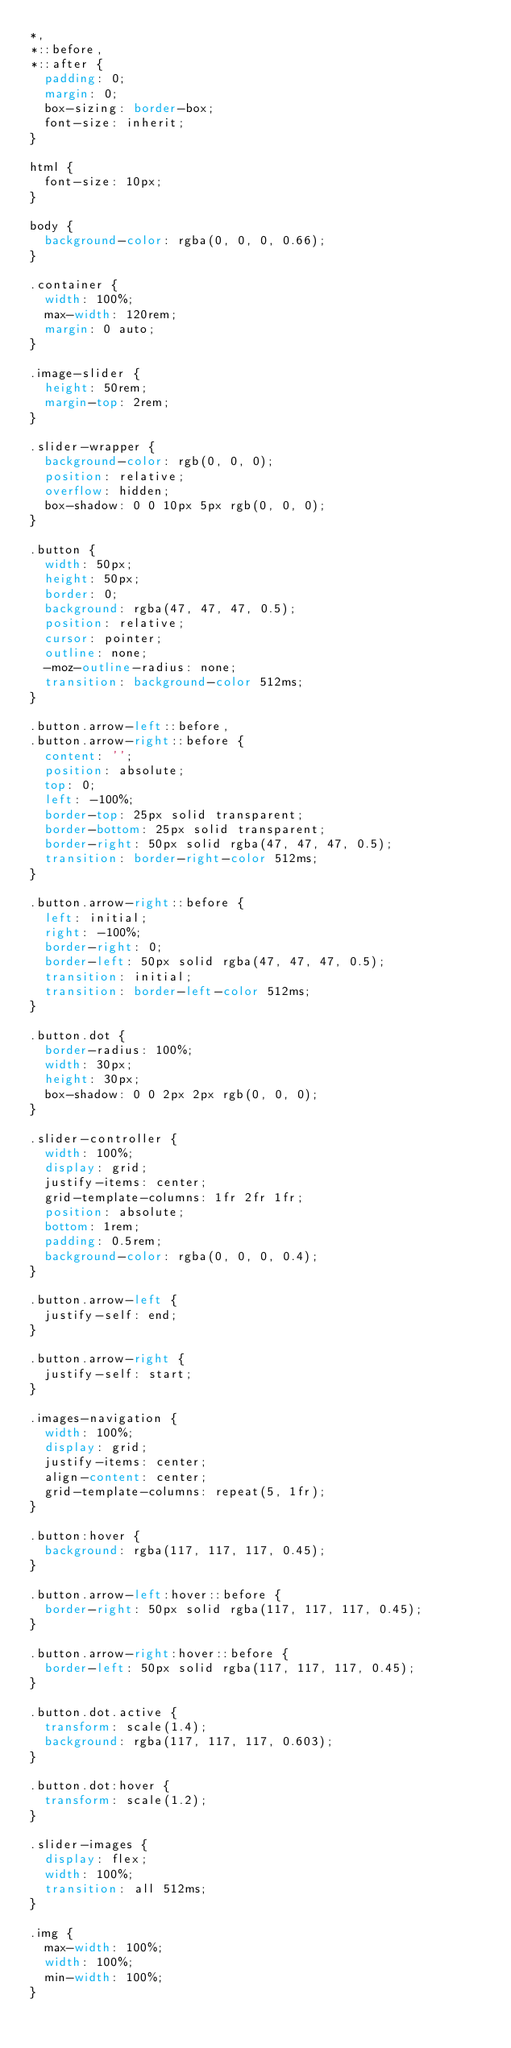<code> <loc_0><loc_0><loc_500><loc_500><_CSS_>*,
*::before,
*::after {
  padding: 0;
  margin: 0;
  box-sizing: border-box;
  font-size: inherit;
}

html {
  font-size: 10px;
}

body {
  background-color: rgba(0, 0, 0, 0.66);
}

.container {
  width: 100%;
  max-width: 120rem;
  margin: 0 auto;
}

.image-slider {
  height: 50rem;
  margin-top: 2rem;
}

.slider-wrapper {
  background-color: rgb(0, 0, 0);
  position: relative;
  overflow: hidden;
  box-shadow: 0 0 10px 5px rgb(0, 0, 0);
}

.button {
  width: 50px;
  height: 50px;
  border: 0;
  background: rgba(47, 47, 47, 0.5);
  position: relative;
  cursor: pointer;
  outline: none;
  -moz-outline-radius: none;
  transition: background-color 512ms;
}

.button.arrow-left::before,
.button.arrow-right::before {
  content: '';
  position: absolute;
  top: 0;
  left: -100%;
  border-top: 25px solid transparent;
  border-bottom: 25px solid transparent;
  border-right: 50px solid rgba(47, 47, 47, 0.5);
  transition: border-right-color 512ms;
}

.button.arrow-right::before {
  left: initial;
  right: -100%;
  border-right: 0;
  border-left: 50px solid rgba(47, 47, 47, 0.5);
  transition: initial;
  transition: border-left-color 512ms;
}

.button.dot {
  border-radius: 100%;
  width: 30px;
  height: 30px;
  box-shadow: 0 0 2px 2px rgb(0, 0, 0);
}

.slider-controller {
  width: 100%;
  display: grid;
  justify-items: center;
  grid-template-columns: 1fr 2fr 1fr;
  position: absolute;
  bottom: 1rem;
  padding: 0.5rem;
  background-color: rgba(0, 0, 0, 0.4);
}

.button.arrow-left {
  justify-self: end;
}

.button.arrow-right {
  justify-self: start;
}

.images-navigation {
  width: 100%;
  display: grid;
  justify-items: center;
  align-content: center;
  grid-template-columns: repeat(5, 1fr);
}

.button:hover {
  background: rgba(117, 117, 117, 0.45);
}

.button.arrow-left:hover::before {
  border-right: 50px solid rgba(117, 117, 117, 0.45);
}

.button.arrow-right:hover::before {
  border-left: 50px solid rgba(117, 117, 117, 0.45);
}

.button.dot.active {
  transform: scale(1.4);
  background: rgba(117, 117, 117, 0.603);
}

.button.dot:hover {
  transform: scale(1.2);
}

.slider-images {
  display: flex;
  width: 100%;
  transition: all 512ms;
}

.img {
  max-width: 100%;
  width: 100%;
  min-width: 100%;
}
</code> 